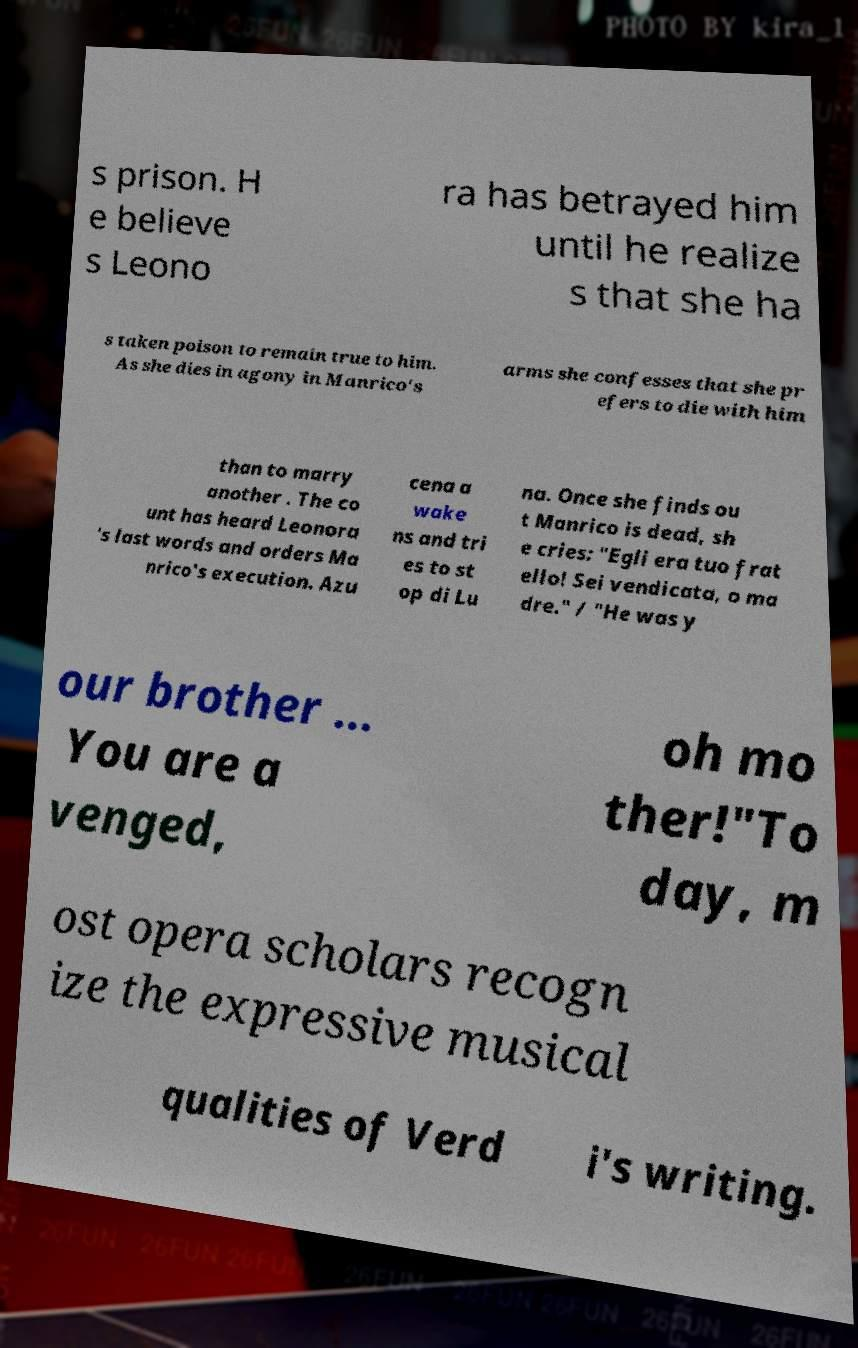For documentation purposes, I need the text within this image transcribed. Could you provide that? s prison. H e believe s Leono ra has betrayed him until he realize s that she ha s taken poison to remain true to him. As she dies in agony in Manrico's arms she confesses that she pr efers to die with him than to marry another . The co unt has heard Leonora 's last words and orders Ma nrico's execution. Azu cena a wake ns and tri es to st op di Lu na. Once she finds ou t Manrico is dead, sh e cries: "Egli era tuo frat ello! Sei vendicata, o ma dre." / "He was y our brother ... You are a venged, oh mo ther!"To day, m ost opera scholars recogn ize the expressive musical qualities of Verd i's writing. 